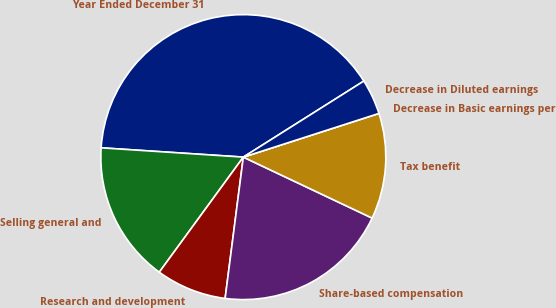Convert chart. <chart><loc_0><loc_0><loc_500><loc_500><pie_chart><fcel>Year Ended December 31<fcel>Selling general and<fcel>Research and development<fcel>Share-based compensation<fcel>Tax benefit<fcel>Decrease in Basic earnings per<fcel>Decrease in Diluted earnings<nl><fcel>40.0%<fcel>16.0%<fcel>8.0%<fcel>20.0%<fcel>12.0%<fcel>0.0%<fcel>4.0%<nl></chart> 